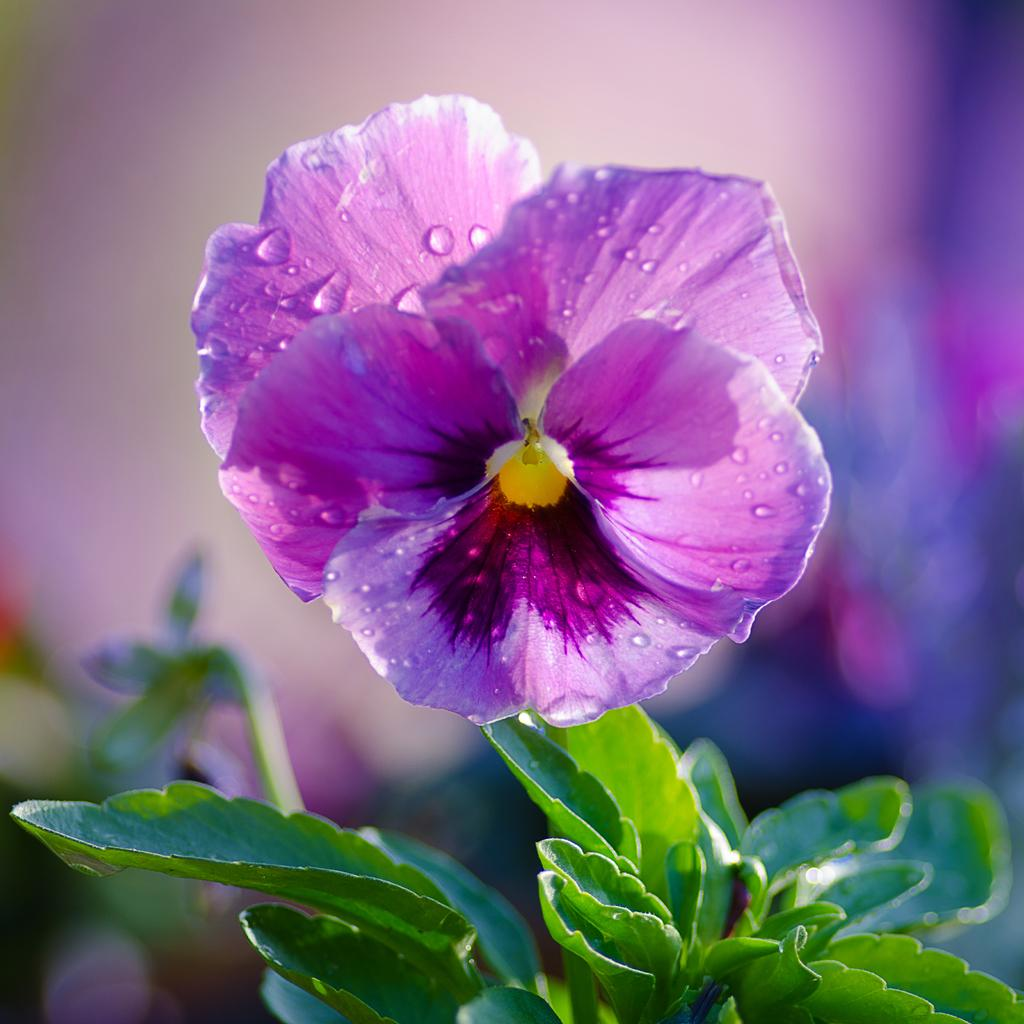What is the main subject of the image? There is a plant in the image. What color is the flower on the plant? The flower on the plant has a violet color. How would you describe the background of the image? The background of the image is blurred. What type of crime is being committed in the image? There is no crime being committed in the image; it features a plant with a violet flower and a blurred background. How does the toothpaste relate to the plant in the image? There is no toothpaste present in the image, and therefore it cannot be related to the plant. 